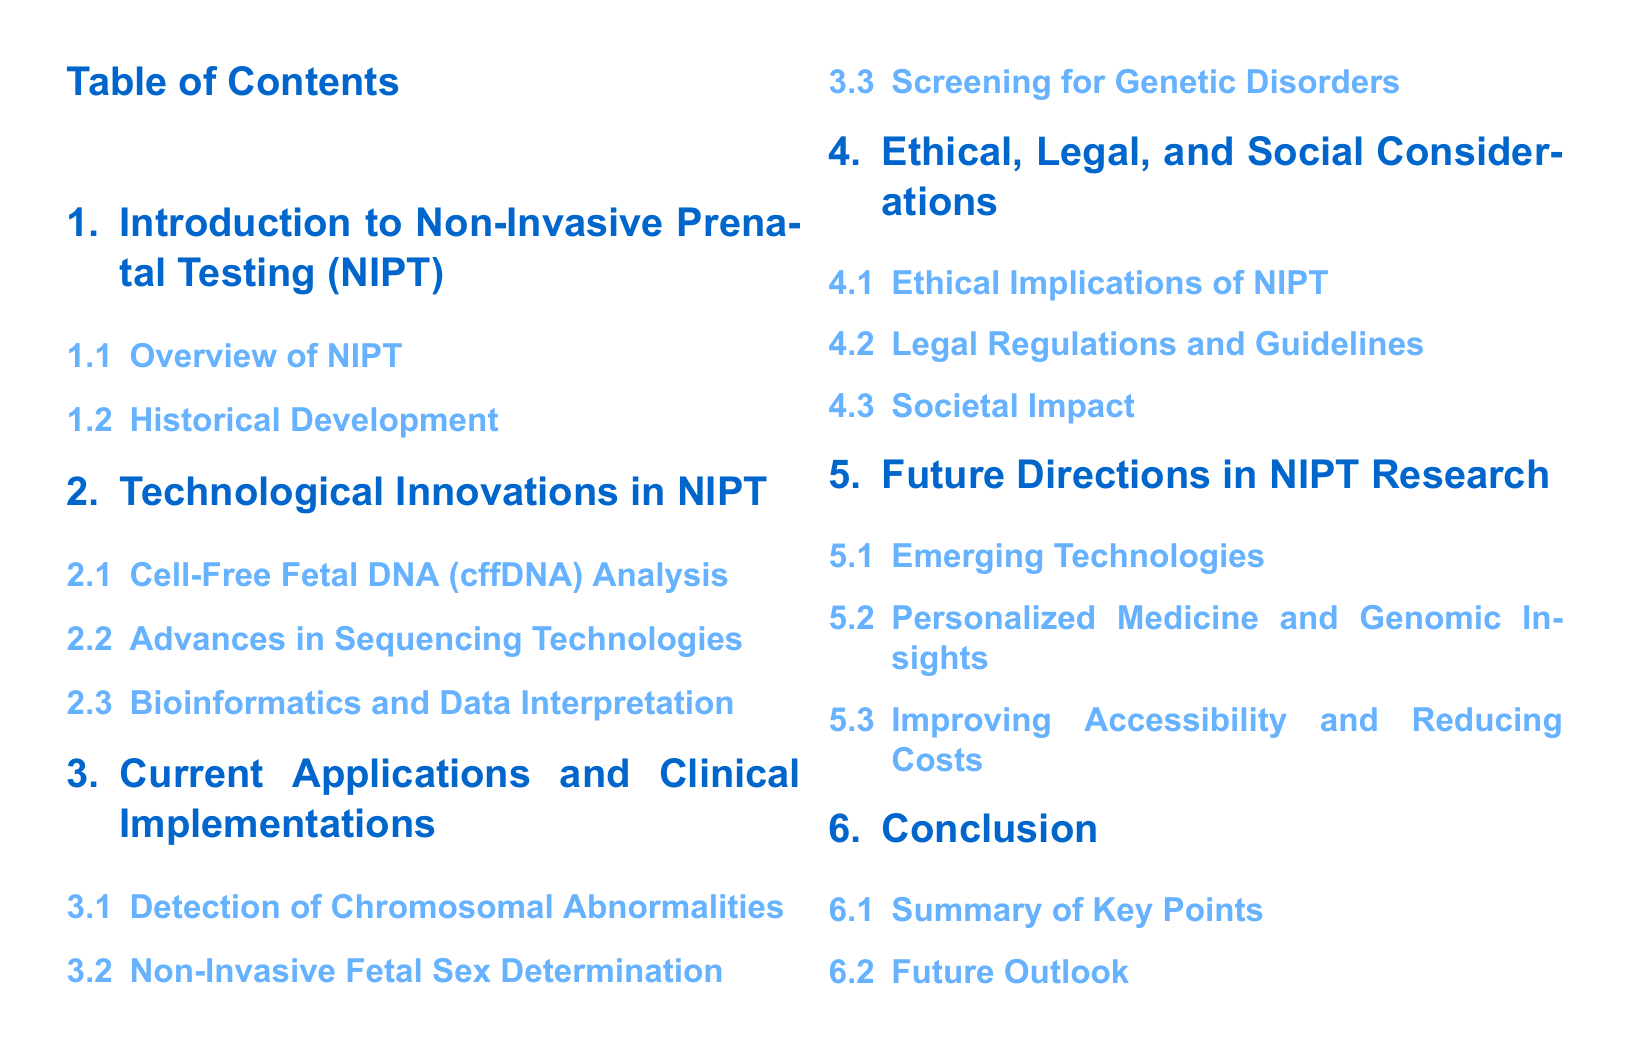What is the first section title in the document? The first section title is found at the beginning of the document, listed in the table of contents.
Answer: Introduction to Non-Invasive Prenatal Testing (NIPT) How many subsections are listed under "Ethical, Legal, and Social Considerations"? To determine the number of subsections, we count the entries under the corresponding section in the table of contents.
Answer: 3 What is one of the applications of NIPT mentioned? The document specifies the applications listed in relation to NIPT under its relevant section.
Answer: Detection of Chromosomal Abnormalities Which technology is specifically highlighted in the section on technological innovations? The table of contents indicates specific technologies that are innovations in NIPT, which can be found there.
Answer: Cell-Free Fetal DNA (cffDNA) Analysis What is the last section in the table of contents? The last section can be found by looking at the final entry in the listed sections of the table of contents.
Answer: Conclusion What is the main focus of the section titled "Future Directions in NIPT Research"? The section's title provides insight into what readers can anticipate regarding advancements and research in NIPT.
Answer: Emerging Technologies How many main sections are in the document? The total number of main sections can be counted based on the main titles present in the table of contents.
Answer: 6 